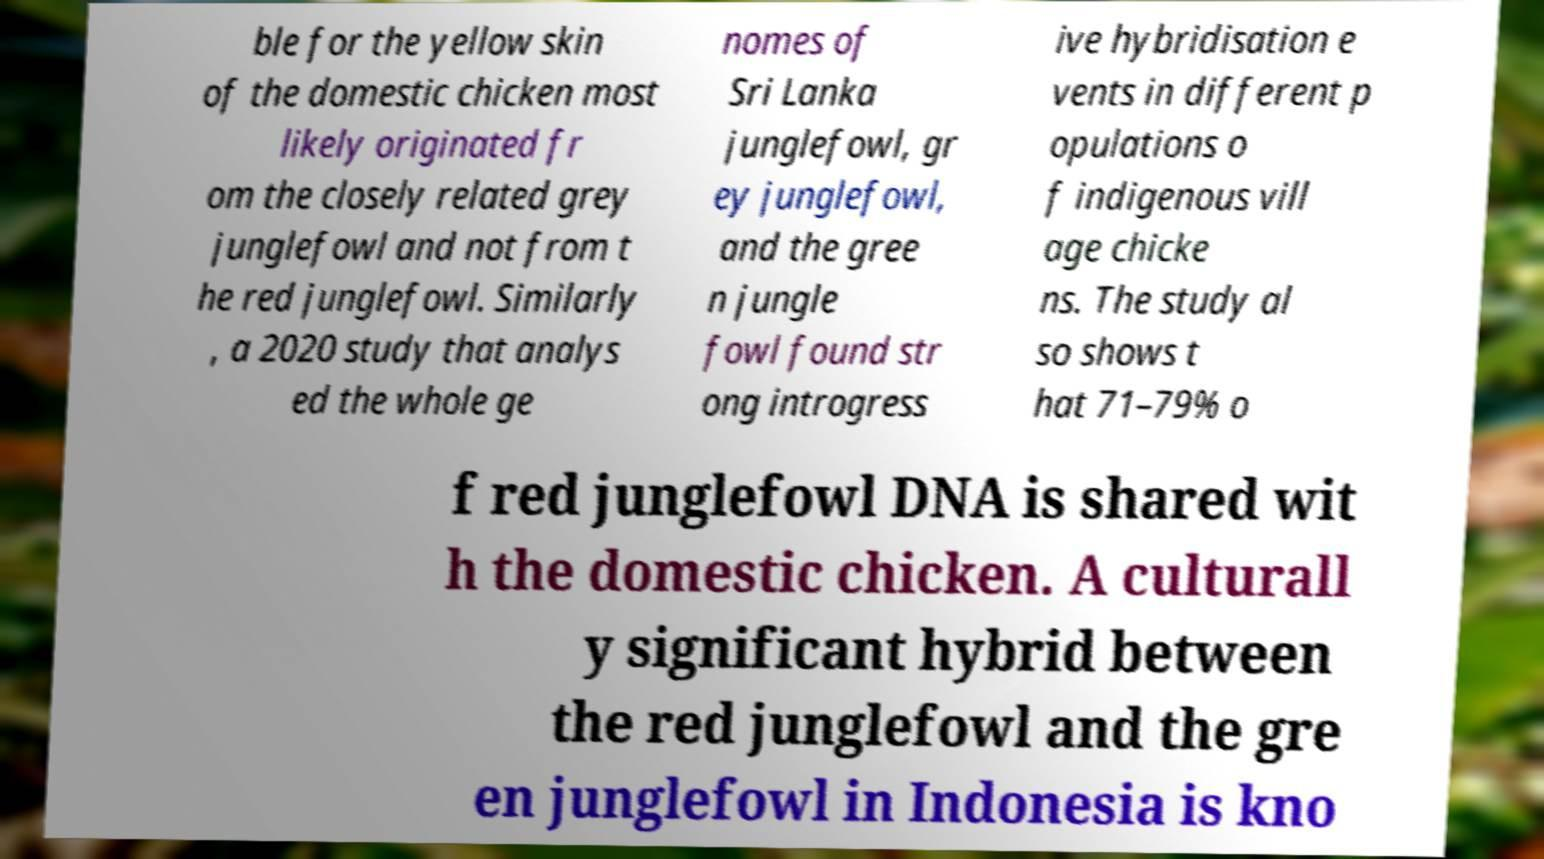Can you accurately transcribe the text from the provided image for me? ble for the yellow skin of the domestic chicken most likely originated fr om the closely related grey junglefowl and not from t he red junglefowl. Similarly , a 2020 study that analys ed the whole ge nomes of Sri Lanka junglefowl, gr ey junglefowl, and the gree n jungle fowl found str ong introgress ive hybridisation e vents in different p opulations o f indigenous vill age chicke ns. The study al so shows t hat 71–79% o f red junglefowl DNA is shared wit h the domestic chicken. A culturall y significant hybrid between the red junglefowl and the gre en junglefowl in Indonesia is kno 